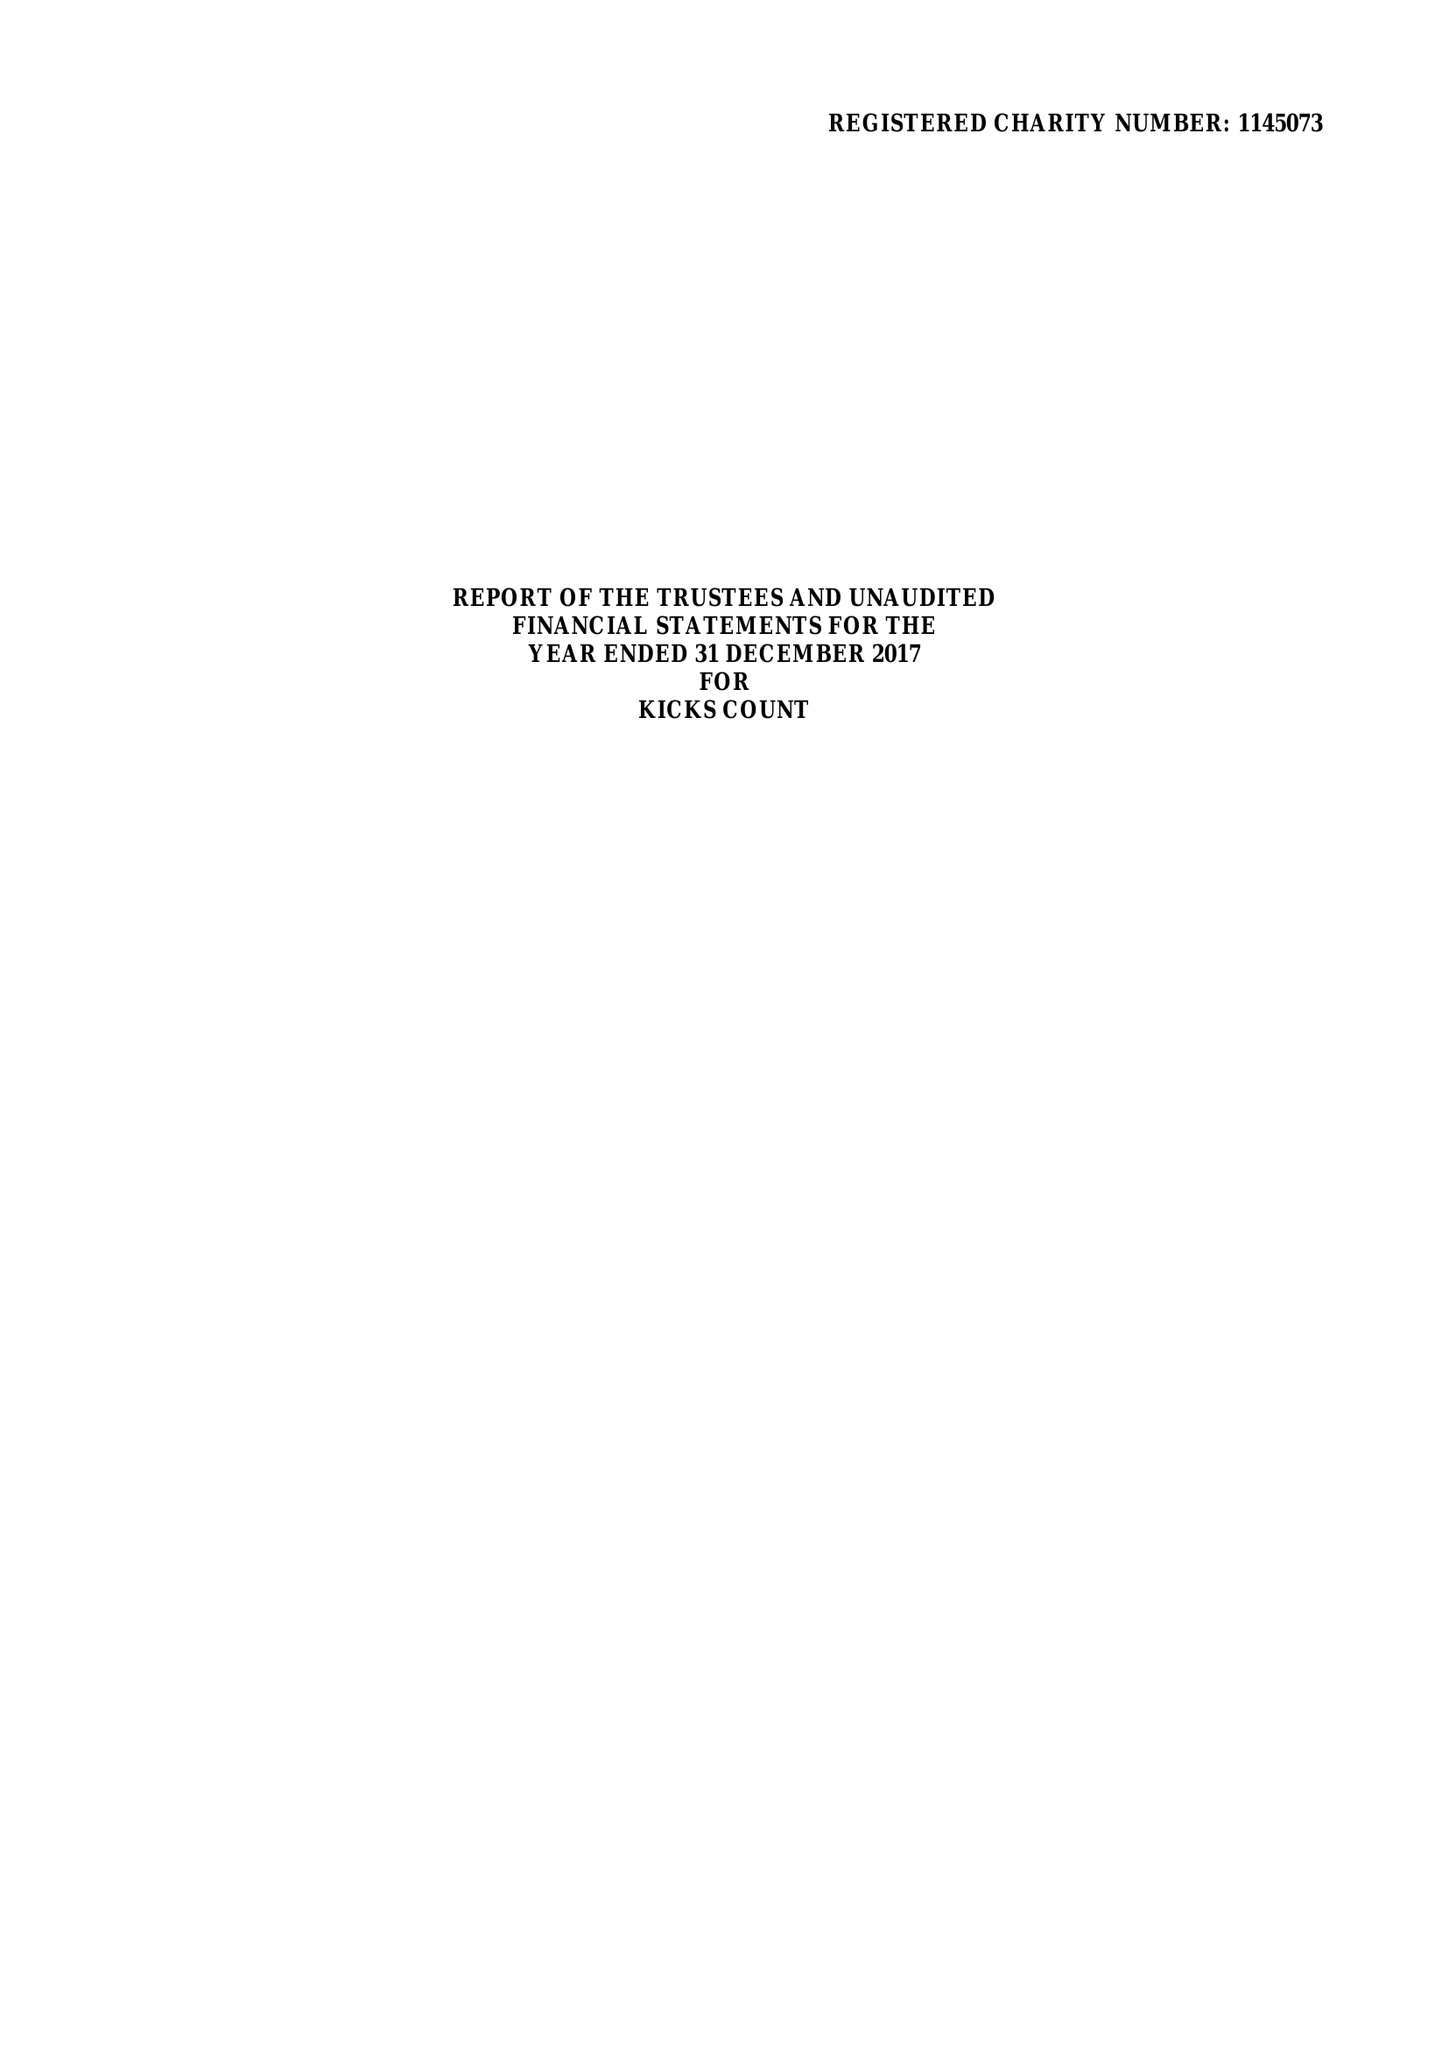What is the value for the address__post_town?
Answer the question using a single word or phrase. WOKING 